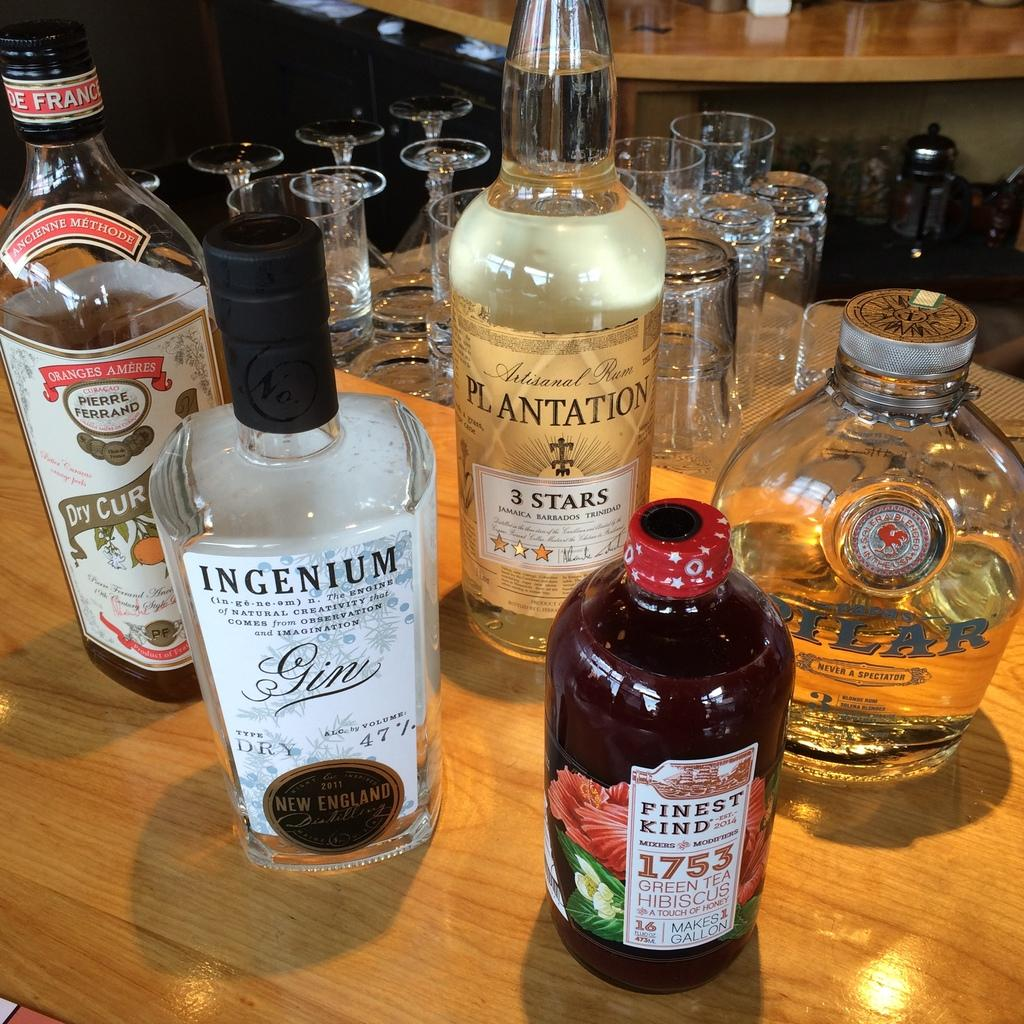<image>
Render a clear and concise summary of the photo. a bottle of ingenium gin next to other bottles 